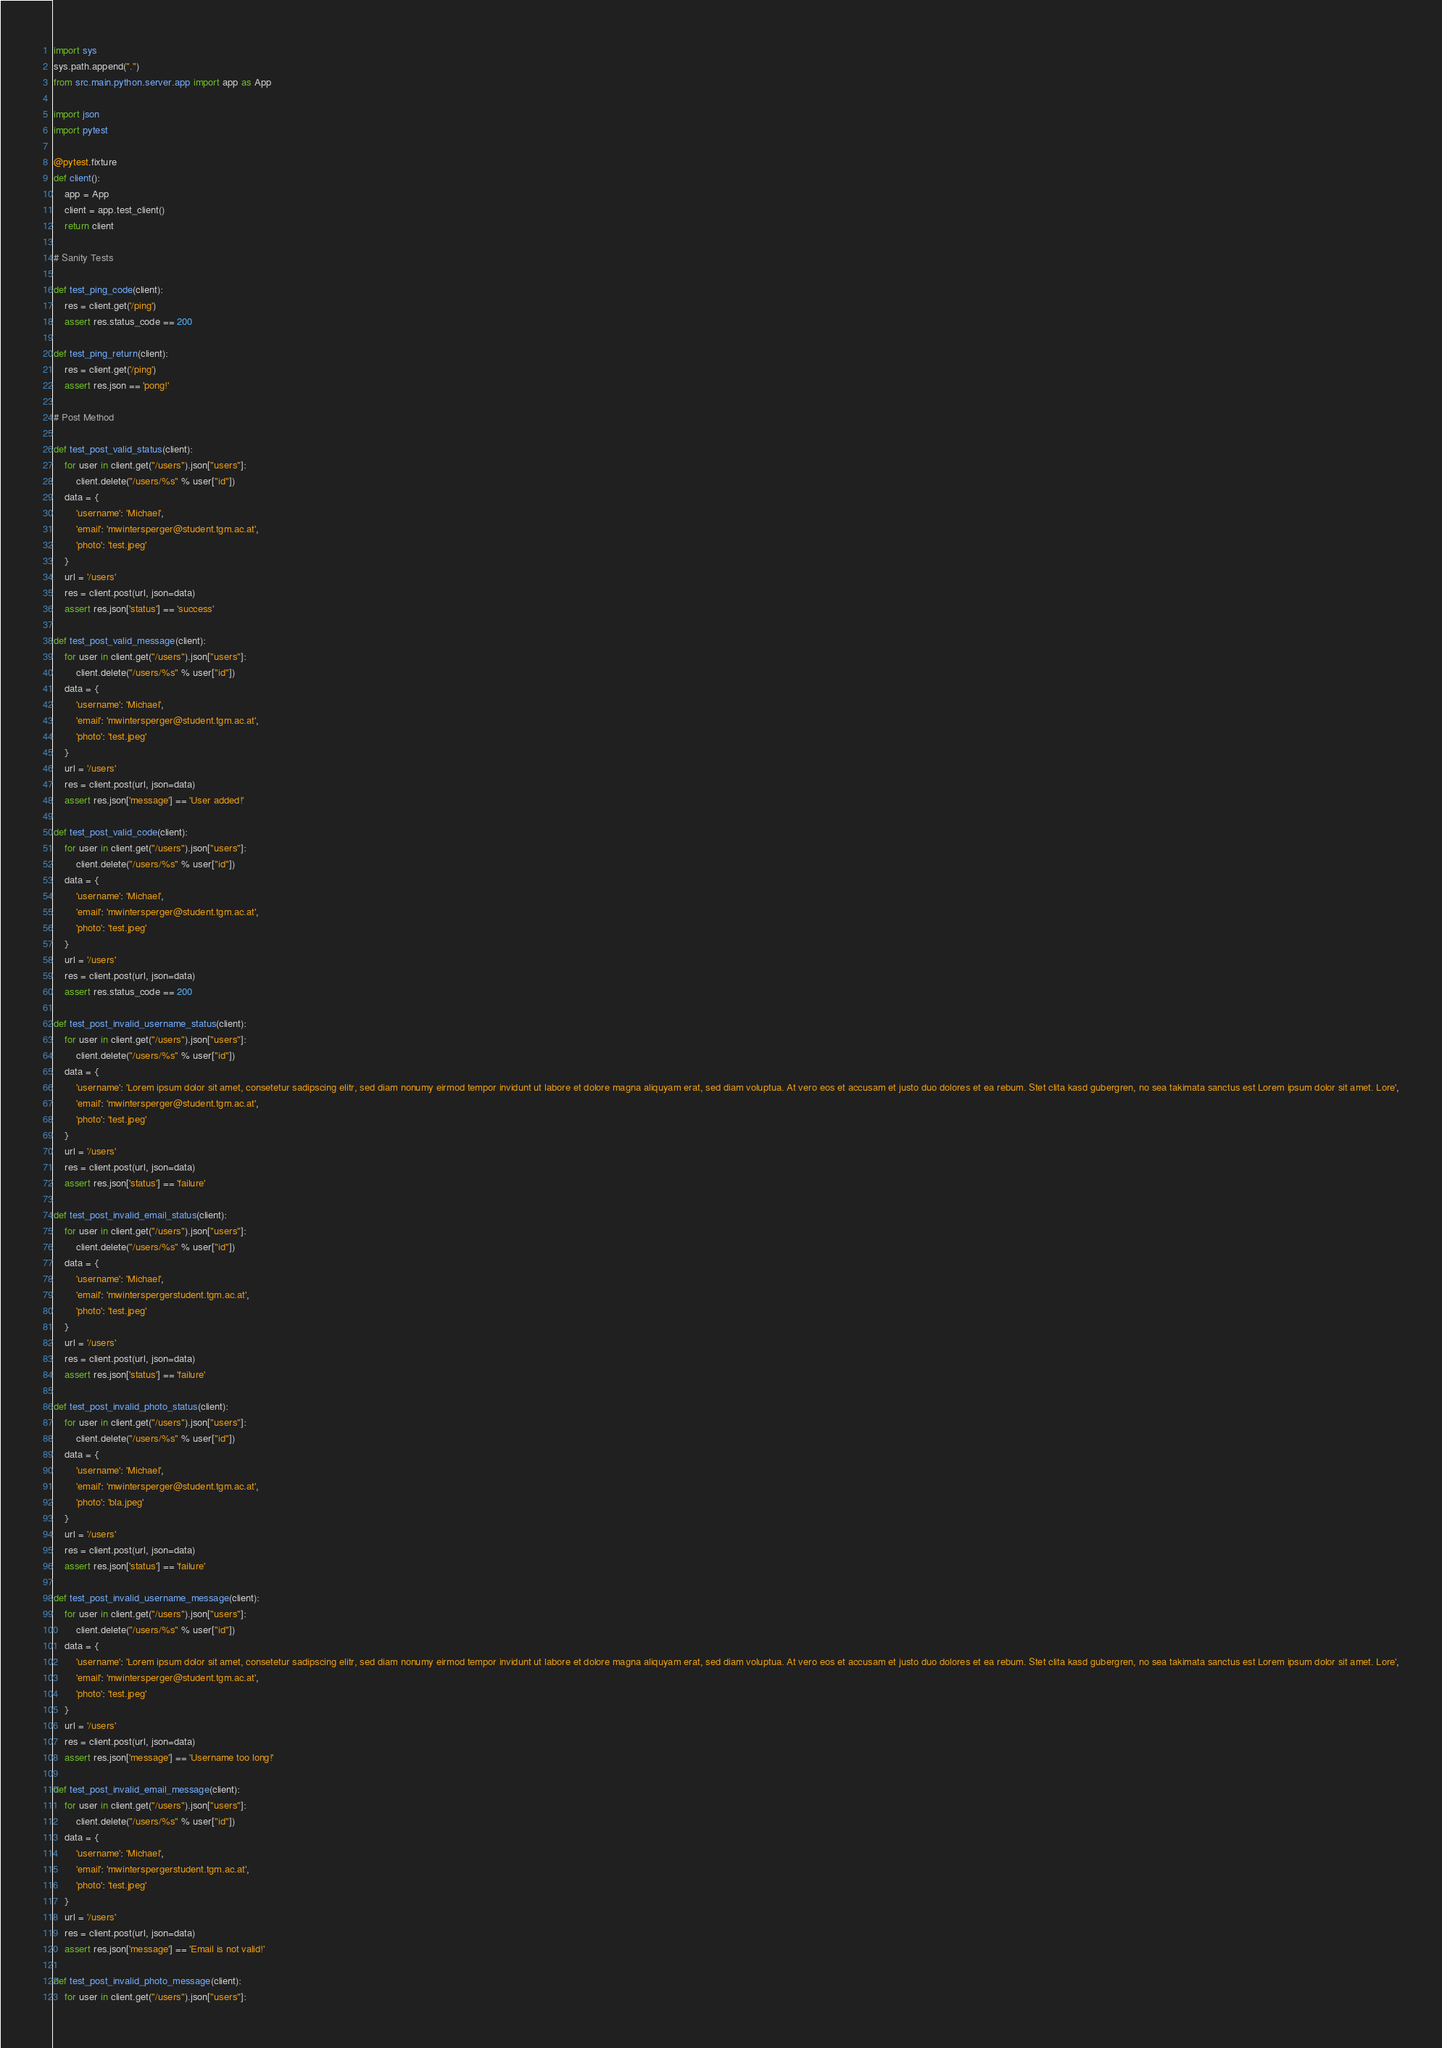Convert code to text. <code><loc_0><loc_0><loc_500><loc_500><_Python_>import sys
sys.path.append(".")
from src.main.python.server.app import app as App

import json
import pytest

@pytest.fixture
def client():
    app = App
    client = app.test_client()
    return client

# Sanity Tests

def test_ping_code(client):
    res = client.get('/ping')
    assert res.status_code == 200

def test_ping_return(client):
    res = client.get('/ping')
    assert res.json == 'pong!'

# Post Method

def test_post_valid_status(client):
    for user in client.get("/users").json["users"]:
        client.delete("/users/%s" % user["id"])
    data = {
        'username': 'Michael',
        'email': 'mwintersperger@student.tgm.ac.at',
        'photo': 'test.jpeg'
    }
    url = '/users'
    res = client.post(url, json=data)
    assert res.json['status'] == 'success'

def test_post_valid_message(client):
    for user in client.get("/users").json["users"]:
        client.delete("/users/%s" % user["id"])
    data = {
        'username': 'Michael',
        'email': 'mwintersperger@student.tgm.ac.at',
        'photo': 'test.jpeg'
    }
    url = '/users'
    res = client.post(url, json=data)
    assert res.json['message'] == 'User added!'

def test_post_valid_code(client):
    for user in client.get("/users").json["users"]:
        client.delete("/users/%s" % user["id"])
    data = {
        'username': 'Michael',
        'email': 'mwintersperger@student.tgm.ac.at',
        'photo': 'test.jpeg'
    }
    url = '/users'
    res = client.post(url, json=data)
    assert res.status_code == 200

def test_post_invalid_username_status(client):
    for user in client.get("/users").json["users"]:
        client.delete("/users/%s" % user["id"])
    data = {
        'username': 'Lorem ipsum dolor sit amet, consetetur sadipscing elitr, sed diam nonumy eirmod tempor invidunt ut labore et dolore magna aliquyam erat, sed diam voluptua. At vero eos et accusam et justo duo dolores et ea rebum. Stet clita kasd gubergren, no sea takimata sanctus est Lorem ipsum dolor sit amet. Lore',
        'email': 'mwintersperger@student.tgm.ac.at',
        'photo': 'test.jpeg'
    }
    url = '/users'
    res = client.post(url, json=data)
    assert res.json['status'] == 'failure'

def test_post_invalid_email_status(client):
    for user in client.get("/users").json["users"]:
        client.delete("/users/%s" % user["id"])
    data = {
        'username': 'Michael',
        'email': 'mwinterspergerstudent.tgm.ac.at',
        'photo': 'test.jpeg'
    }
    url = '/users'
    res = client.post(url, json=data)
    assert res.json['status'] == 'failure'

def test_post_invalid_photo_status(client):
    for user in client.get("/users").json["users"]:
        client.delete("/users/%s" % user["id"])
    data = {
        'username': 'Michael',
        'email': 'mwintersperger@student.tgm.ac.at',
        'photo': 'bla.jpeg'
    }
    url = '/users'
    res = client.post(url, json=data)
    assert res.json['status'] == 'failure'

def test_post_invalid_username_message(client):
    for user in client.get("/users").json["users"]:
        client.delete("/users/%s" % user["id"])
    data = {
        'username': 'Lorem ipsum dolor sit amet, consetetur sadipscing elitr, sed diam nonumy eirmod tempor invidunt ut labore et dolore magna aliquyam erat, sed diam voluptua. At vero eos et accusam et justo duo dolores et ea rebum. Stet clita kasd gubergren, no sea takimata sanctus est Lorem ipsum dolor sit amet. Lore',
        'email': 'mwintersperger@student.tgm.ac.at',
        'photo': 'test.jpeg'
    }
    url = '/users'
    res = client.post(url, json=data)
    assert res.json['message'] == 'Username too long!'

def test_post_invalid_email_message(client):
    for user in client.get("/users").json["users"]:
        client.delete("/users/%s" % user["id"])
    data = {
        'username': 'Michael',
        'email': 'mwinterspergerstudent.tgm.ac.at',
        'photo': 'test.jpeg'
    }
    url = '/users'
    res = client.post(url, json=data)
    assert res.json['message'] == 'Email is not valid!'

def test_post_invalid_photo_message(client):
    for user in client.get("/users").json["users"]:</code> 